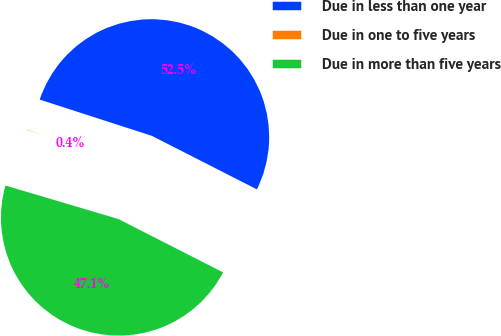Convert chart to OTSL. <chart><loc_0><loc_0><loc_500><loc_500><pie_chart><fcel>Due in less than one year<fcel>Due in one to five years<fcel>Due in more than five years<nl><fcel>52.52%<fcel>0.39%<fcel>47.09%<nl></chart> 